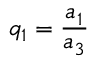Convert formula to latex. <formula><loc_0><loc_0><loc_500><loc_500>q _ { 1 } = \frac { a _ { 1 } } { a _ { 3 } }</formula> 